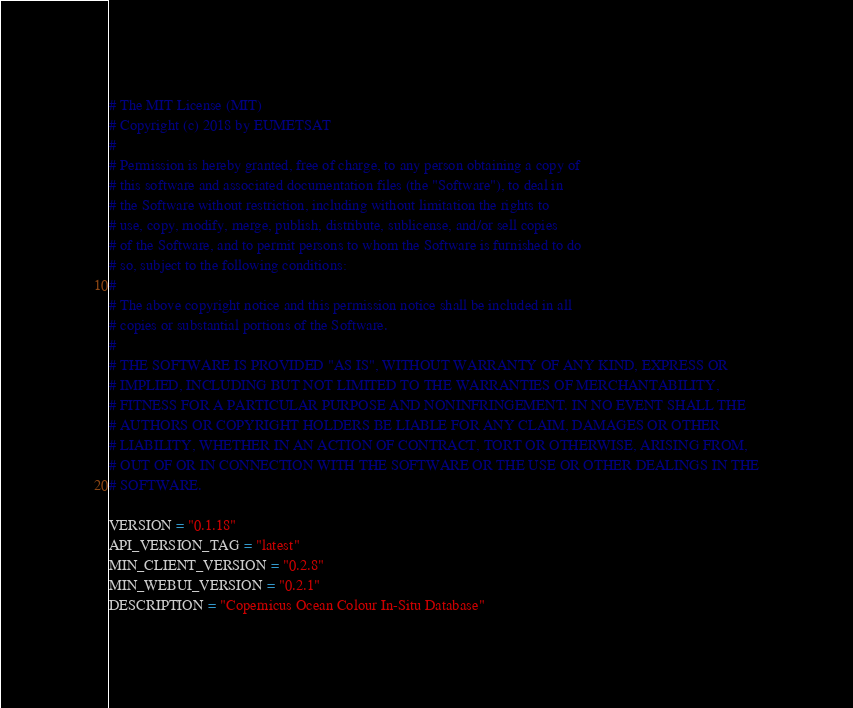Convert code to text. <code><loc_0><loc_0><loc_500><loc_500><_Python_># The MIT License (MIT)
# Copyright (c) 2018 by EUMETSAT
#
# Permission is hereby granted, free of charge, to any person obtaining a copy of
# this software and associated documentation files (the "Software"), to deal in
# the Software without restriction, including without limitation the rights to
# use, copy, modify, merge, publish, distribute, sublicense, and/or sell copies
# of the Software, and to permit persons to whom the Software is furnished to do
# so, subject to the following conditions:
#
# The above copyright notice and this permission notice shall be included in all
# copies or substantial portions of the Software.
#
# THE SOFTWARE IS PROVIDED "AS IS", WITHOUT WARRANTY OF ANY KIND, EXPRESS OR
# IMPLIED, INCLUDING BUT NOT LIMITED TO THE WARRANTIES OF MERCHANTABILITY,
# FITNESS FOR A PARTICULAR PURPOSE AND NONINFRINGEMENT. IN NO EVENT SHALL THE
# AUTHORS OR COPYRIGHT HOLDERS BE LIABLE FOR ANY CLAIM, DAMAGES OR OTHER
# LIABILITY, WHETHER IN AN ACTION OF CONTRACT, TORT OR OTHERWISE, ARISING FROM,
# OUT OF OR IN CONNECTION WITH THE SOFTWARE OR THE USE OR OTHER DEALINGS IN THE
# SOFTWARE.

VERSION = "0.1.18"
API_VERSION_TAG = "latest"
MIN_CLIENT_VERSION = "0.2.8"
MIN_WEBUI_VERSION = "0.2.1"
DESCRIPTION = "Copernicus Ocean Colour In-Situ Database"
</code> 